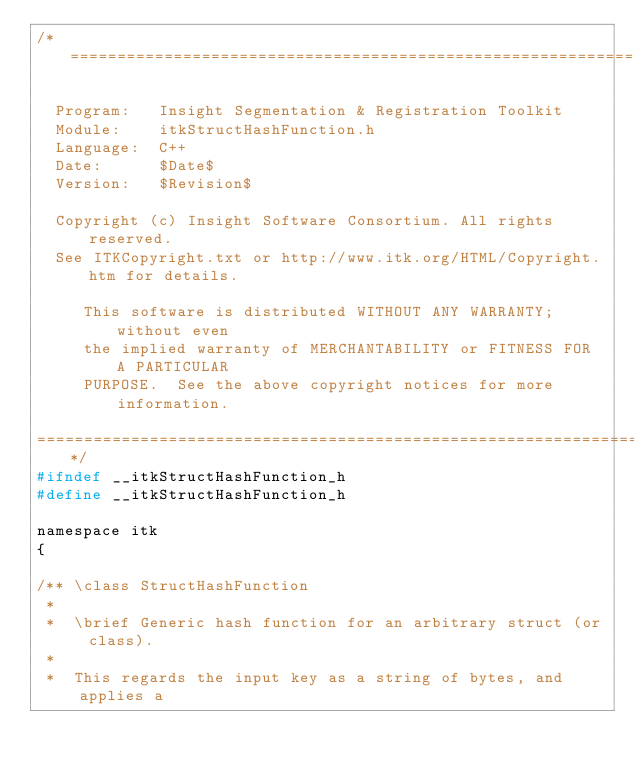Convert code to text. <code><loc_0><loc_0><loc_500><loc_500><_C_>/*=========================================================================

  Program:   Insight Segmentation & Registration Toolkit
  Module:    itkStructHashFunction.h
  Language:  C++
  Date:      $Date$
  Version:   $Revision$

  Copyright (c) Insight Software Consortium. All rights reserved.
  See ITKCopyright.txt or http://www.itk.org/HTML/Copyright.htm for details.

     This software is distributed WITHOUT ANY WARRANTY; without even 
     the implied warranty of MERCHANTABILITY or FITNESS FOR A PARTICULAR 
     PURPOSE.  See the above copyright notices for more information.

=========================================================================*/
#ifndef __itkStructHashFunction_h
#define __itkStructHashFunction_h

namespace itk
{

/** \class StructHashFunction
 *
 *  \brief Generic hash function for an arbitrary struct (or class).
 *
 *  This regards the input key as a string of bytes, and applies a</code> 